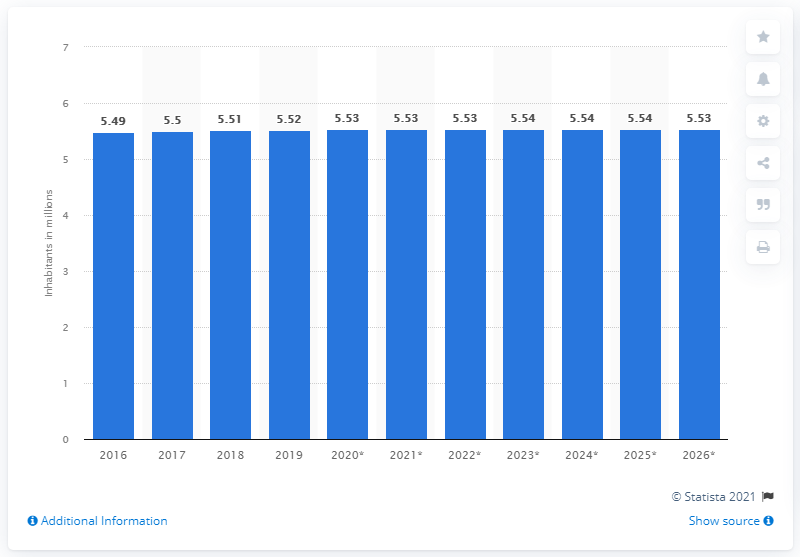Give some essential details in this illustration. In 2019, the population of Finland was approximately 5.53 million. 